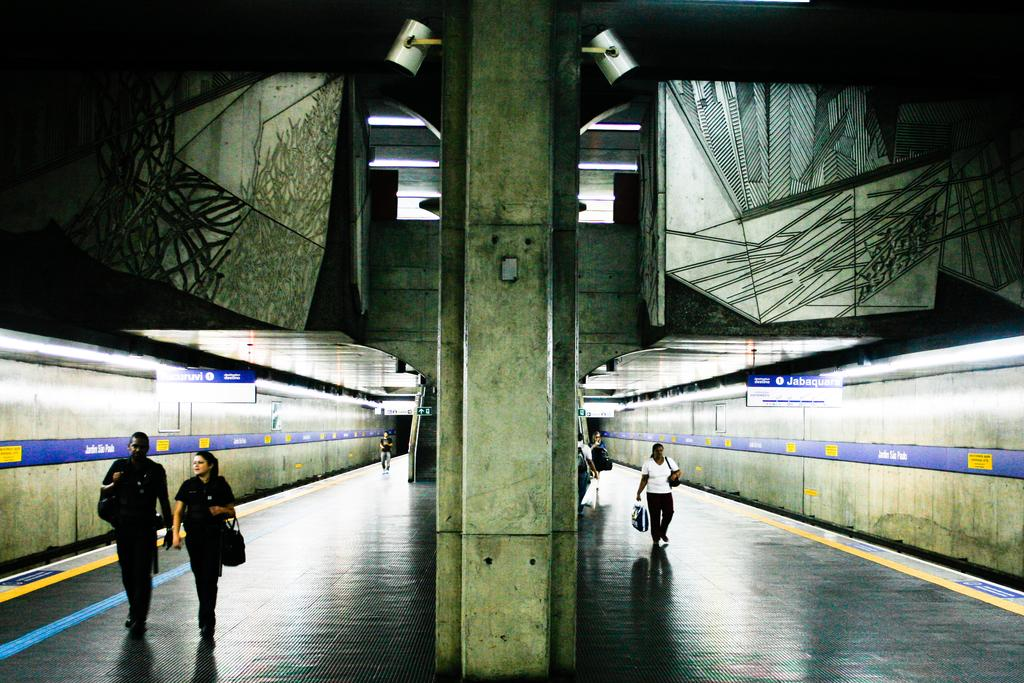Who or what can be seen in the image? There are people in the image. What is the background of the image? There is a wall in the image. What type of vehicles are present in the image? There are trains in the image. What type of lettuce is being used as a hat by one of the people in the image? There is no lettuce present in the image, nor is anyone wearing lettuce as a hat. 